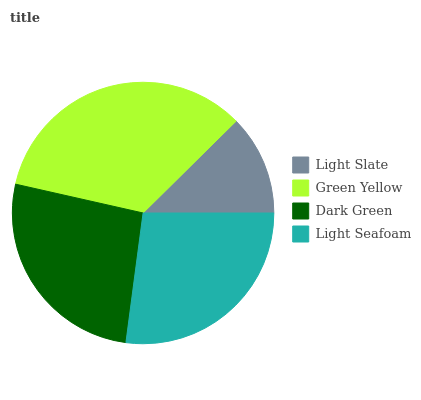Is Light Slate the minimum?
Answer yes or no. Yes. Is Green Yellow the maximum?
Answer yes or no. Yes. Is Dark Green the minimum?
Answer yes or no. No. Is Dark Green the maximum?
Answer yes or no. No. Is Green Yellow greater than Dark Green?
Answer yes or no. Yes. Is Dark Green less than Green Yellow?
Answer yes or no. Yes. Is Dark Green greater than Green Yellow?
Answer yes or no. No. Is Green Yellow less than Dark Green?
Answer yes or no. No. Is Light Seafoam the high median?
Answer yes or no. Yes. Is Dark Green the low median?
Answer yes or no. Yes. Is Dark Green the high median?
Answer yes or no. No. Is Green Yellow the low median?
Answer yes or no. No. 